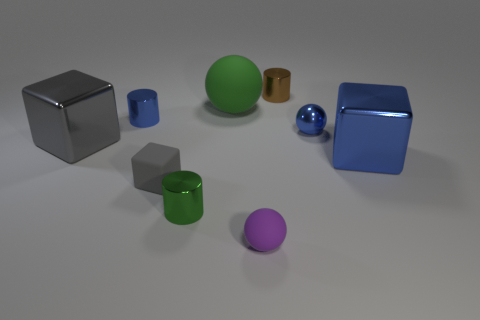Subtract all gray metal cubes. How many cubes are left? 2 Subtract all blue blocks. How many blocks are left? 2 Subtract 1 purple spheres. How many objects are left? 8 Subtract all cubes. How many objects are left? 6 Subtract 1 cubes. How many cubes are left? 2 Subtract all yellow cylinders. Subtract all purple balls. How many cylinders are left? 3 Subtract all green blocks. How many purple cylinders are left? 0 Subtract all small metal objects. Subtract all big gray shiny things. How many objects are left? 4 Add 9 small purple matte spheres. How many small purple matte spheres are left? 10 Add 8 big gray rubber cubes. How many big gray rubber cubes exist? 8 